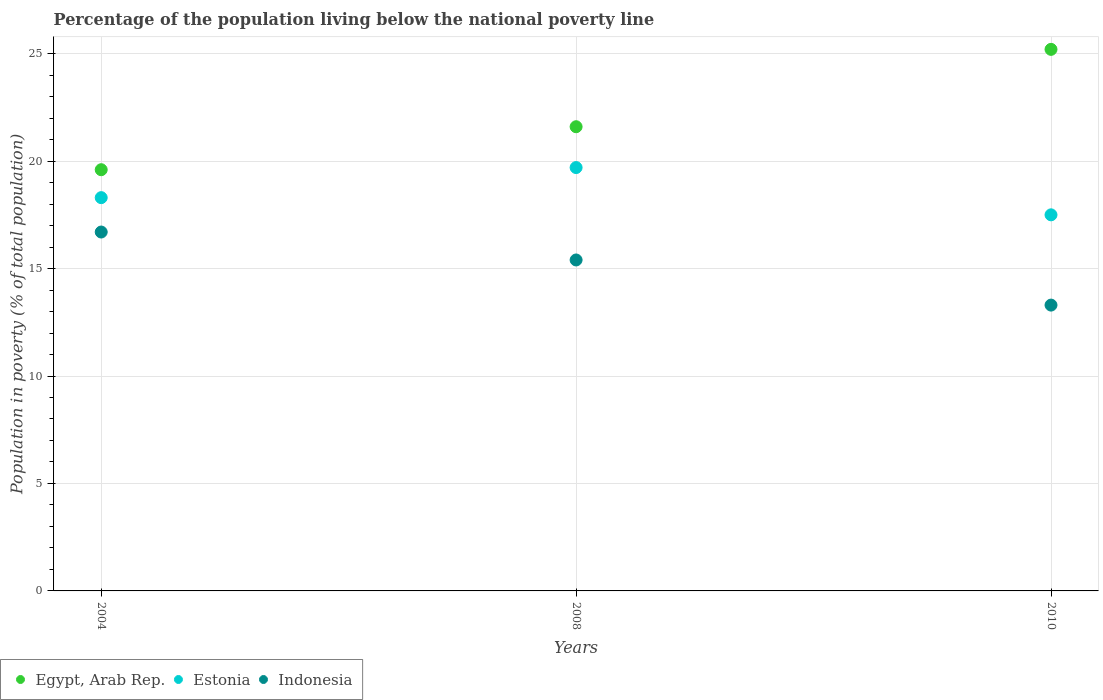Is the number of dotlines equal to the number of legend labels?
Your response must be concise. Yes. What is the percentage of the population living below the national poverty line in Egypt, Arab Rep. in 2008?
Your response must be concise. 21.6. Across all years, what is the maximum percentage of the population living below the national poverty line in Egypt, Arab Rep.?
Your response must be concise. 25.2. Across all years, what is the minimum percentage of the population living below the national poverty line in Egypt, Arab Rep.?
Keep it short and to the point. 19.6. In which year was the percentage of the population living below the national poverty line in Indonesia maximum?
Ensure brevity in your answer.  2004. What is the total percentage of the population living below the national poverty line in Egypt, Arab Rep. in the graph?
Your answer should be very brief. 66.4. What is the difference between the percentage of the population living below the national poverty line in Egypt, Arab Rep. in 2004 and that in 2008?
Ensure brevity in your answer.  -2. What is the difference between the percentage of the population living below the national poverty line in Egypt, Arab Rep. in 2008 and the percentage of the population living below the national poverty line in Indonesia in 2010?
Keep it short and to the point. 8.3. In the year 2008, what is the difference between the percentage of the population living below the national poverty line in Estonia and percentage of the population living below the national poverty line in Egypt, Arab Rep.?
Your answer should be compact. -1.9. What is the ratio of the percentage of the population living below the national poverty line in Estonia in 2008 to that in 2010?
Your response must be concise. 1.13. Is the percentage of the population living below the national poverty line in Indonesia in 2008 less than that in 2010?
Ensure brevity in your answer.  No. Is the difference between the percentage of the population living below the national poverty line in Estonia in 2008 and 2010 greater than the difference between the percentage of the population living below the national poverty line in Egypt, Arab Rep. in 2008 and 2010?
Your answer should be very brief. Yes. What is the difference between the highest and the second highest percentage of the population living below the national poverty line in Estonia?
Provide a short and direct response. 1.4. What is the difference between the highest and the lowest percentage of the population living below the national poverty line in Indonesia?
Your answer should be compact. 3.4. In how many years, is the percentage of the population living below the national poverty line in Indonesia greater than the average percentage of the population living below the national poverty line in Indonesia taken over all years?
Provide a short and direct response. 2. Is the sum of the percentage of the population living below the national poverty line in Estonia in 2004 and 2008 greater than the maximum percentage of the population living below the national poverty line in Indonesia across all years?
Offer a very short reply. Yes. Is it the case that in every year, the sum of the percentage of the population living below the national poverty line in Estonia and percentage of the population living below the national poverty line in Egypt, Arab Rep.  is greater than the percentage of the population living below the national poverty line in Indonesia?
Make the answer very short. Yes. Does the percentage of the population living below the national poverty line in Indonesia monotonically increase over the years?
Your response must be concise. No. Is the percentage of the population living below the national poverty line in Estonia strictly less than the percentage of the population living below the national poverty line in Egypt, Arab Rep. over the years?
Your answer should be very brief. Yes. What is the difference between two consecutive major ticks on the Y-axis?
Provide a succinct answer. 5. Are the values on the major ticks of Y-axis written in scientific E-notation?
Keep it short and to the point. No. Does the graph contain any zero values?
Keep it short and to the point. No. Does the graph contain grids?
Your answer should be compact. Yes. Where does the legend appear in the graph?
Make the answer very short. Bottom left. How many legend labels are there?
Ensure brevity in your answer.  3. What is the title of the graph?
Offer a very short reply. Percentage of the population living below the national poverty line. Does "New Zealand" appear as one of the legend labels in the graph?
Make the answer very short. No. What is the label or title of the X-axis?
Your response must be concise. Years. What is the label or title of the Y-axis?
Ensure brevity in your answer.  Population in poverty (% of total population). What is the Population in poverty (% of total population) of Egypt, Arab Rep. in 2004?
Offer a terse response. 19.6. What is the Population in poverty (% of total population) of Egypt, Arab Rep. in 2008?
Offer a terse response. 21.6. What is the Population in poverty (% of total population) in Indonesia in 2008?
Provide a succinct answer. 15.4. What is the Population in poverty (% of total population) of Egypt, Arab Rep. in 2010?
Give a very brief answer. 25.2. What is the Population in poverty (% of total population) in Indonesia in 2010?
Your response must be concise. 13.3. Across all years, what is the maximum Population in poverty (% of total population) in Egypt, Arab Rep.?
Keep it short and to the point. 25.2. Across all years, what is the maximum Population in poverty (% of total population) in Estonia?
Make the answer very short. 19.7. Across all years, what is the minimum Population in poverty (% of total population) in Egypt, Arab Rep.?
Give a very brief answer. 19.6. Across all years, what is the minimum Population in poverty (% of total population) of Estonia?
Your answer should be compact. 17.5. Across all years, what is the minimum Population in poverty (% of total population) in Indonesia?
Your answer should be compact. 13.3. What is the total Population in poverty (% of total population) of Egypt, Arab Rep. in the graph?
Make the answer very short. 66.4. What is the total Population in poverty (% of total population) in Estonia in the graph?
Offer a very short reply. 55.5. What is the total Population in poverty (% of total population) in Indonesia in the graph?
Provide a succinct answer. 45.4. What is the difference between the Population in poverty (% of total population) of Estonia in 2004 and that in 2008?
Your answer should be very brief. -1.4. What is the difference between the Population in poverty (% of total population) of Indonesia in 2004 and that in 2008?
Ensure brevity in your answer.  1.3. What is the difference between the Population in poverty (% of total population) in Egypt, Arab Rep. in 2004 and that in 2010?
Offer a terse response. -5.6. What is the difference between the Population in poverty (% of total population) of Indonesia in 2004 and that in 2010?
Ensure brevity in your answer.  3.4. What is the difference between the Population in poverty (% of total population) of Egypt, Arab Rep. in 2008 and that in 2010?
Make the answer very short. -3.6. What is the difference between the Population in poverty (% of total population) of Estonia in 2008 and that in 2010?
Your answer should be compact. 2.2. What is the difference between the Population in poverty (% of total population) of Egypt, Arab Rep. in 2004 and the Population in poverty (% of total population) of Indonesia in 2010?
Offer a terse response. 6.3. What is the difference between the Population in poverty (% of total population) of Estonia in 2008 and the Population in poverty (% of total population) of Indonesia in 2010?
Your answer should be compact. 6.4. What is the average Population in poverty (% of total population) of Egypt, Arab Rep. per year?
Offer a very short reply. 22.13. What is the average Population in poverty (% of total population) in Estonia per year?
Ensure brevity in your answer.  18.5. What is the average Population in poverty (% of total population) in Indonesia per year?
Ensure brevity in your answer.  15.13. In the year 2004, what is the difference between the Population in poverty (% of total population) in Egypt, Arab Rep. and Population in poverty (% of total population) in Estonia?
Make the answer very short. 1.3. In the year 2008, what is the difference between the Population in poverty (% of total population) of Estonia and Population in poverty (% of total population) of Indonesia?
Ensure brevity in your answer.  4.3. In the year 2010, what is the difference between the Population in poverty (% of total population) in Egypt, Arab Rep. and Population in poverty (% of total population) in Indonesia?
Provide a succinct answer. 11.9. What is the ratio of the Population in poverty (% of total population) of Egypt, Arab Rep. in 2004 to that in 2008?
Provide a short and direct response. 0.91. What is the ratio of the Population in poverty (% of total population) in Estonia in 2004 to that in 2008?
Provide a succinct answer. 0.93. What is the ratio of the Population in poverty (% of total population) of Indonesia in 2004 to that in 2008?
Ensure brevity in your answer.  1.08. What is the ratio of the Population in poverty (% of total population) of Egypt, Arab Rep. in 2004 to that in 2010?
Provide a succinct answer. 0.78. What is the ratio of the Population in poverty (% of total population) in Estonia in 2004 to that in 2010?
Keep it short and to the point. 1.05. What is the ratio of the Population in poverty (% of total population) of Indonesia in 2004 to that in 2010?
Make the answer very short. 1.26. What is the ratio of the Population in poverty (% of total population) in Egypt, Arab Rep. in 2008 to that in 2010?
Provide a succinct answer. 0.86. What is the ratio of the Population in poverty (% of total population) in Estonia in 2008 to that in 2010?
Make the answer very short. 1.13. What is the ratio of the Population in poverty (% of total population) of Indonesia in 2008 to that in 2010?
Give a very brief answer. 1.16. What is the difference between the highest and the lowest Population in poverty (% of total population) in Egypt, Arab Rep.?
Your answer should be compact. 5.6. What is the difference between the highest and the lowest Population in poverty (% of total population) in Estonia?
Offer a terse response. 2.2. What is the difference between the highest and the lowest Population in poverty (% of total population) of Indonesia?
Offer a terse response. 3.4. 